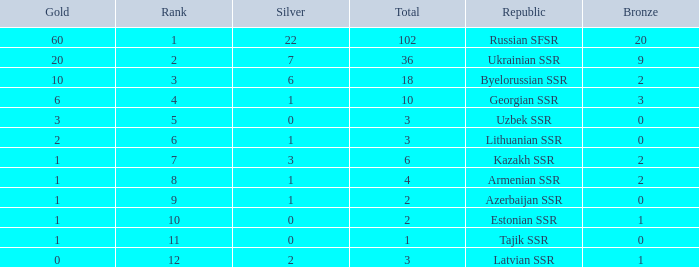What is the highest number of bronzes for teams ranked number 7 with more than 0 silver? 2.0. 